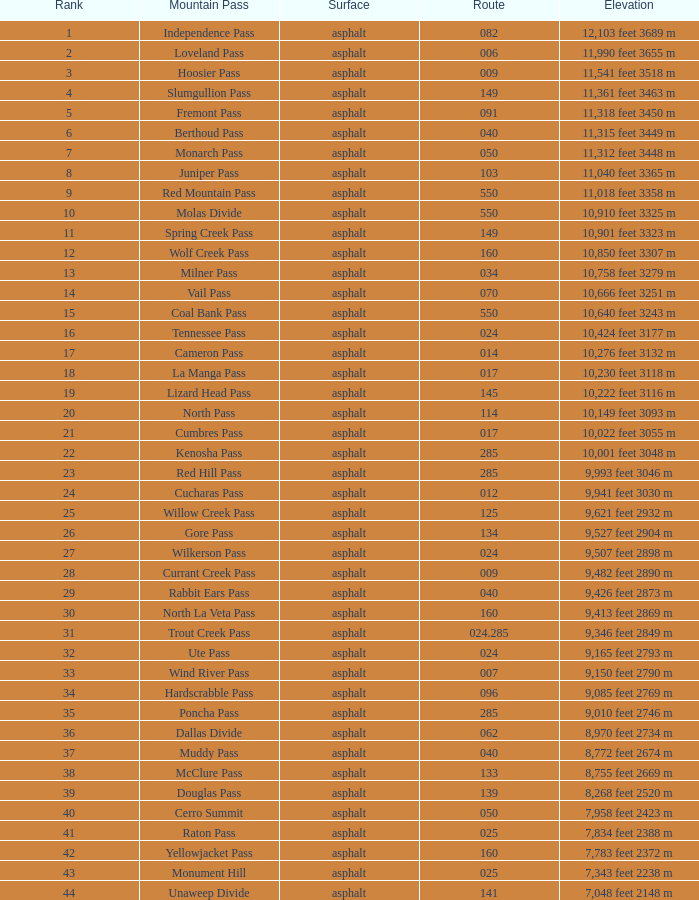Can you parse all the data within this table? {'header': ['Rank', 'Mountain Pass', 'Surface', 'Route', 'Elevation'], 'rows': [['1', 'Independence Pass', 'asphalt', '082', '12,103 feet 3689 m'], ['2', 'Loveland Pass', 'asphalt', '006', '11,990 feet 3655 m'], ['3', 'Hoosier Pass', 'asphalt', '009', '11,541 feet 3518 m'], ['4', 'Slumgullion Pass', 'asphalt', '149', '11,361 feet 3463 m'], ['5', 'Fremont Pass', 'asphalt', '091', '11,318 feet 3450 m'], ['6', 'Berthoud Pass', 'asphalt', '040', '11,315 feet 3449 m'], ['7', 'Monarch Pass', 'asphalt', '050', '11,312 feet 3448 m'], ['8', 'Juniper Pass', 'asphalt', '103', '11,040 feet 3365 m'], ['9', 'Red Mountain Pass', 'asphalt', '550', '11,018 feet 3358 m'], ['10', 'Molas Divide', 'asphalt', '550', '10,910 feet 3325 m'], ['11', 'Spring Creek Pass', 'asphalt', '149', '10,901 feet 3323 m'], ['12', 'Wolf Creek Pass', 'asphalt', '160', '10,850 feet 3307 m'], ['13', 'Milner Pass', 'asphalt', '034', '10,758 feet 3279 m'], ['14', 'Vail Pass', 'asphalt', '070', '10,666 feet 3251 m'], ['15', 'Coal Bank Pass', 'asphalt', '550', '10,640 feet 3243 m'], ['16', 'Tennessee Pass', 'asphalt', '024', '10,424 feet 3177 m'], ['17', 'Cameron Pass', 'asphalt', '014', '10,276 feet 3132 m'], ['18', 'La Manga Pass', 'asphalt', '017', '10,230 feet 3118 m'], ['19', 'Lizard Head Pass', 'asphalt', '145', '10,222 feet 3116 m'], ['20', 'North Pass', 'asphalt', '114', '10,149 feet 3093 m'], ['21', 'Cumbres Pass', 'asphalt', '017', '10,022 feet 3055 m'], ['22', 'Kenosha Pass', 'asphalt', '285', '10,001 feet 3048 m'], ['23', 'Red Hill Pass', 'asphalt', '285', '9,993 feet 3046 m'], ['24', 'Cucharas Pass', 'asphalt', '012', '9,941 feet 3030 m'], ['25', 'Willow Creek Pass', 'asphalt', '125', '9,621 feet 2932 m'], ['26', 'Gore Pass', 'asphalt', '134', '9,527 feet 2904 m'], ['27', 'Wilkerson Pass', 'asphalt', '024', '9,507 feet 2898 m'], ['28', 'Currant Creek Pass', 'asphalt', '009', '9,482 feet 2890 m'], ['29', 'Rabbit Ears Pass', 'asphalt', '040', '9,426 feet 2873 m'], ['30', 'North La Veta Pass', 'asphalt', '160', '9,413 feet 2869 m'], ['31', 'Trout Creek Pass', 'asphalt', '024.285', '9,346 feet 2849 m'], ['32', 'Ute Pass', 'asphalt', '024', '9,165 feet 2793 m'], ['33', 'Wind River Pass', 'asphalt', '007', '9,150 feet 2790 m'], ['34', 'Hardscrabble Pass', 'asphalt', '096', '9,085 feet 2769 m'], ['35', 'Poncha Pass', 'asphalt', '285', '9,010 feet 2746 m'], ['36', 'Dallas Divide', 'asphalt', '062', '8,970 feet 2734 m'], ['37', 'Muddy Pass', 'asphalt', '040', '8,772 feet 2674 m'], ['38', 'McClure Pass', 'asphalt', '133', '8,755 feet 2669 m'], ['39', 'Douglas Pass', 'asphalt', '139', '8,268 feet 2520 m'], ['40', 'Cerro Summit', 'asphalt', '050', '7,958 feet 2423 m'], ['41', 'Raton Pass', 'asphalt', '025', '7,834 feet 2388 m'], ['42', 'Yellowjacket Pass', 'asphalt', '160', '7,783 feet 2372 m'], ['43', 'Monument Hill', 'asphalt', '025', '7,343 feet 2238 m'], ['44', 'Unaweep Divide', 'asphalt', '141', '7,048 feet 2148 m']]} What is the Surface of the Route less than 7? Asphalt. 